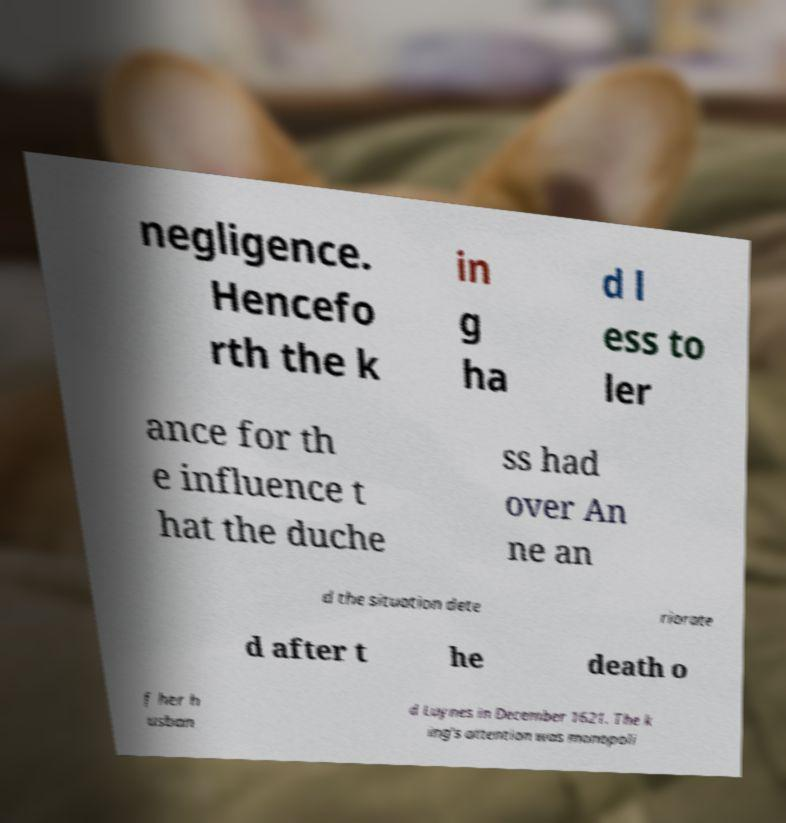For documentation purposes, I need the text within this image transcribed. Could you provide that? negligence. Hencefo rth the k in g ha d l ess to ler ance for th e influence t hat the duche ss had over An ne an d the situation dete riorate d after t he death o f her h usban d Luynes in December 1621. The k ing's attention was monopoli 